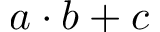<formula> <loc_0><loc_0><loc_500><loc_500>a \cdot b + c</formula> 